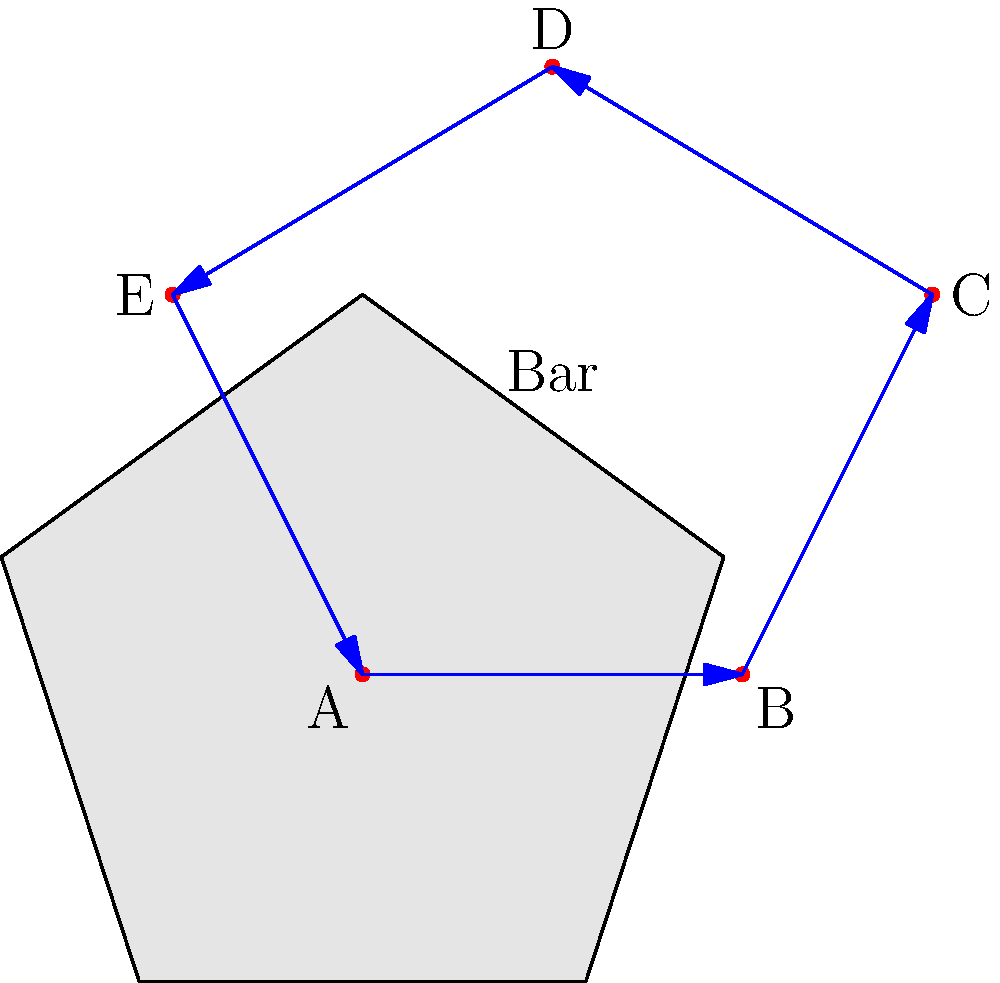Your rooftop bar has a unique pentagonal shape as shown in the diagram. To optimize seating arrangements, you want to calculate the perimeter of the bar area. Given that the bar counter follows the edges of the pentagon and the lengths of the sides are: AB = 5m, BC = 3m, CD = 4m, DE = 4m, and EA = 3m, what is the total perimeter of the bar area? To calculate the perimeter of the pentagonal bar area, we need to sum up the lengths of all sides. Let's go through this step-by-step:

1. Identify the given lengths:
   - AB = 5m
   - BC = 3m
   - CD = 4m
   - DE = 4m
   - EA = 3m

2. The perimeter of a polygon is the sum of the lengths of all its sides. In this case, we have a pentagon, so we'll add all five sides:

   Perimeter = AB + BC + CD + DE + EA

3. Substitute the given values:

   Perimeter = 5m + 3m + 4m + 4m + 3m

4. Perform the addition:

   Perimeter = 19m

Therefore, the total perimeter of the bar area is 19 meters.
Answer: 19m 